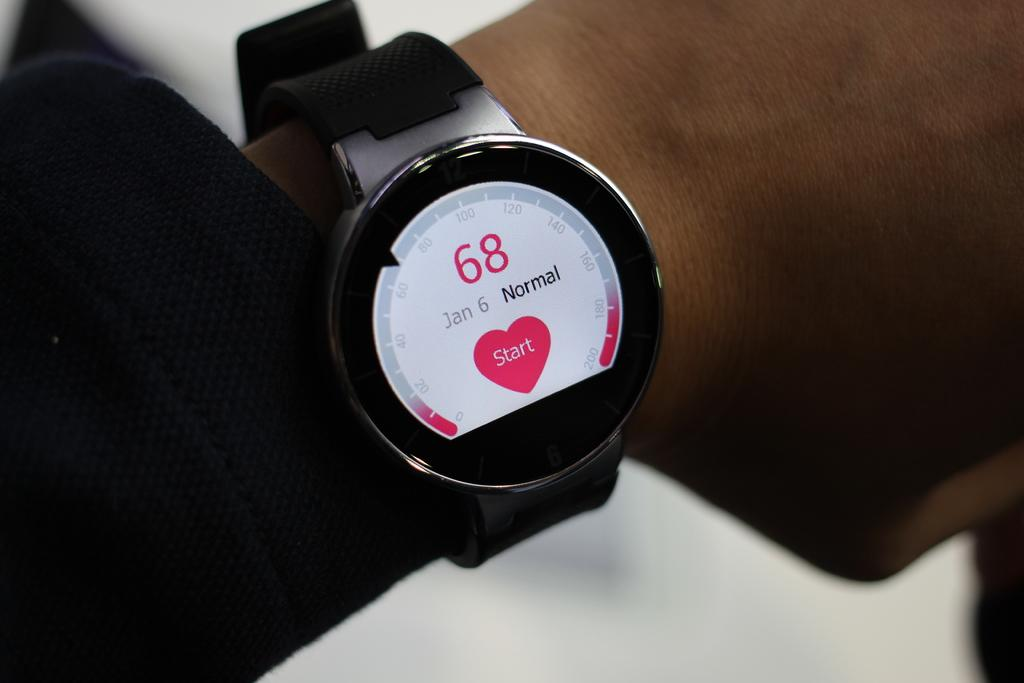<image>
Share a concise interpretation of the image provided. A device to measure the heart rate has 68 and the date of Jan 6. 